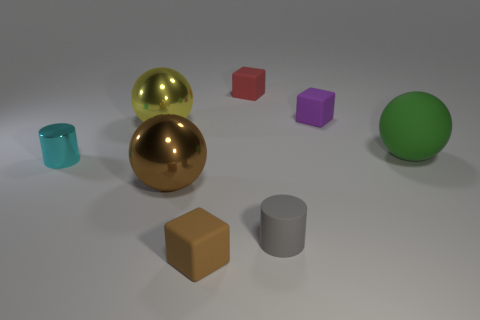What color is the big metallic sphere that is behind the sphere that is to the right of the small gray rubber cylinder?
Provide a succinct answer. Yellow. What is the small cylinder that is to the left of the metal thing behind the tiny cylinder to the left of the small brown block made of?
Your answer should be very brief. Metal. How many red cubes have the same size as the cyan metallic cylinder?
Your response must be concise. 1. What is the large thing that is left of the tiny purple matte object and right of the large yellow thing made of?
Your answer should be very brief. Metal. There is a red block; how many small things are right of it?
Make the answer very short. 2. There is a small purple thing; is its shape the same as the tiny red object left of the big green matte thing?
Keep it short and to the point. Yes. Is there a gray object of the same shape as the cyan object?
Offer a very short reply. Yes. What shape is the large shiny object that is behind the big shiny sphere that is in front of the big yellow metallic object?
Provide a succinct answer. Sphere. There is a big object right of the purple matte cube; what is its shape?
Provide a short and direct response. Sphere. Does the shiny sphere that is right of the big yellow thing have the same color as the rubber block in front of the small gray matte object?
Your answer should be very brief. Yes. 